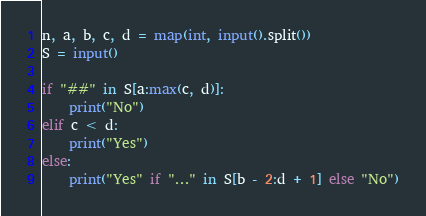Convert code to text. <code><loc_0><loc_0><loc_500><loc_500><_Python_>n, a, b, c, d = map(int, input().split())
S = input()

if "##" in S[a:max(c, d)]:
    print("No")
elif c < d:
    print("Yes")
else:
    print("Yes" if "..." in S[b - 2:d + 1] else "No")
</code> 